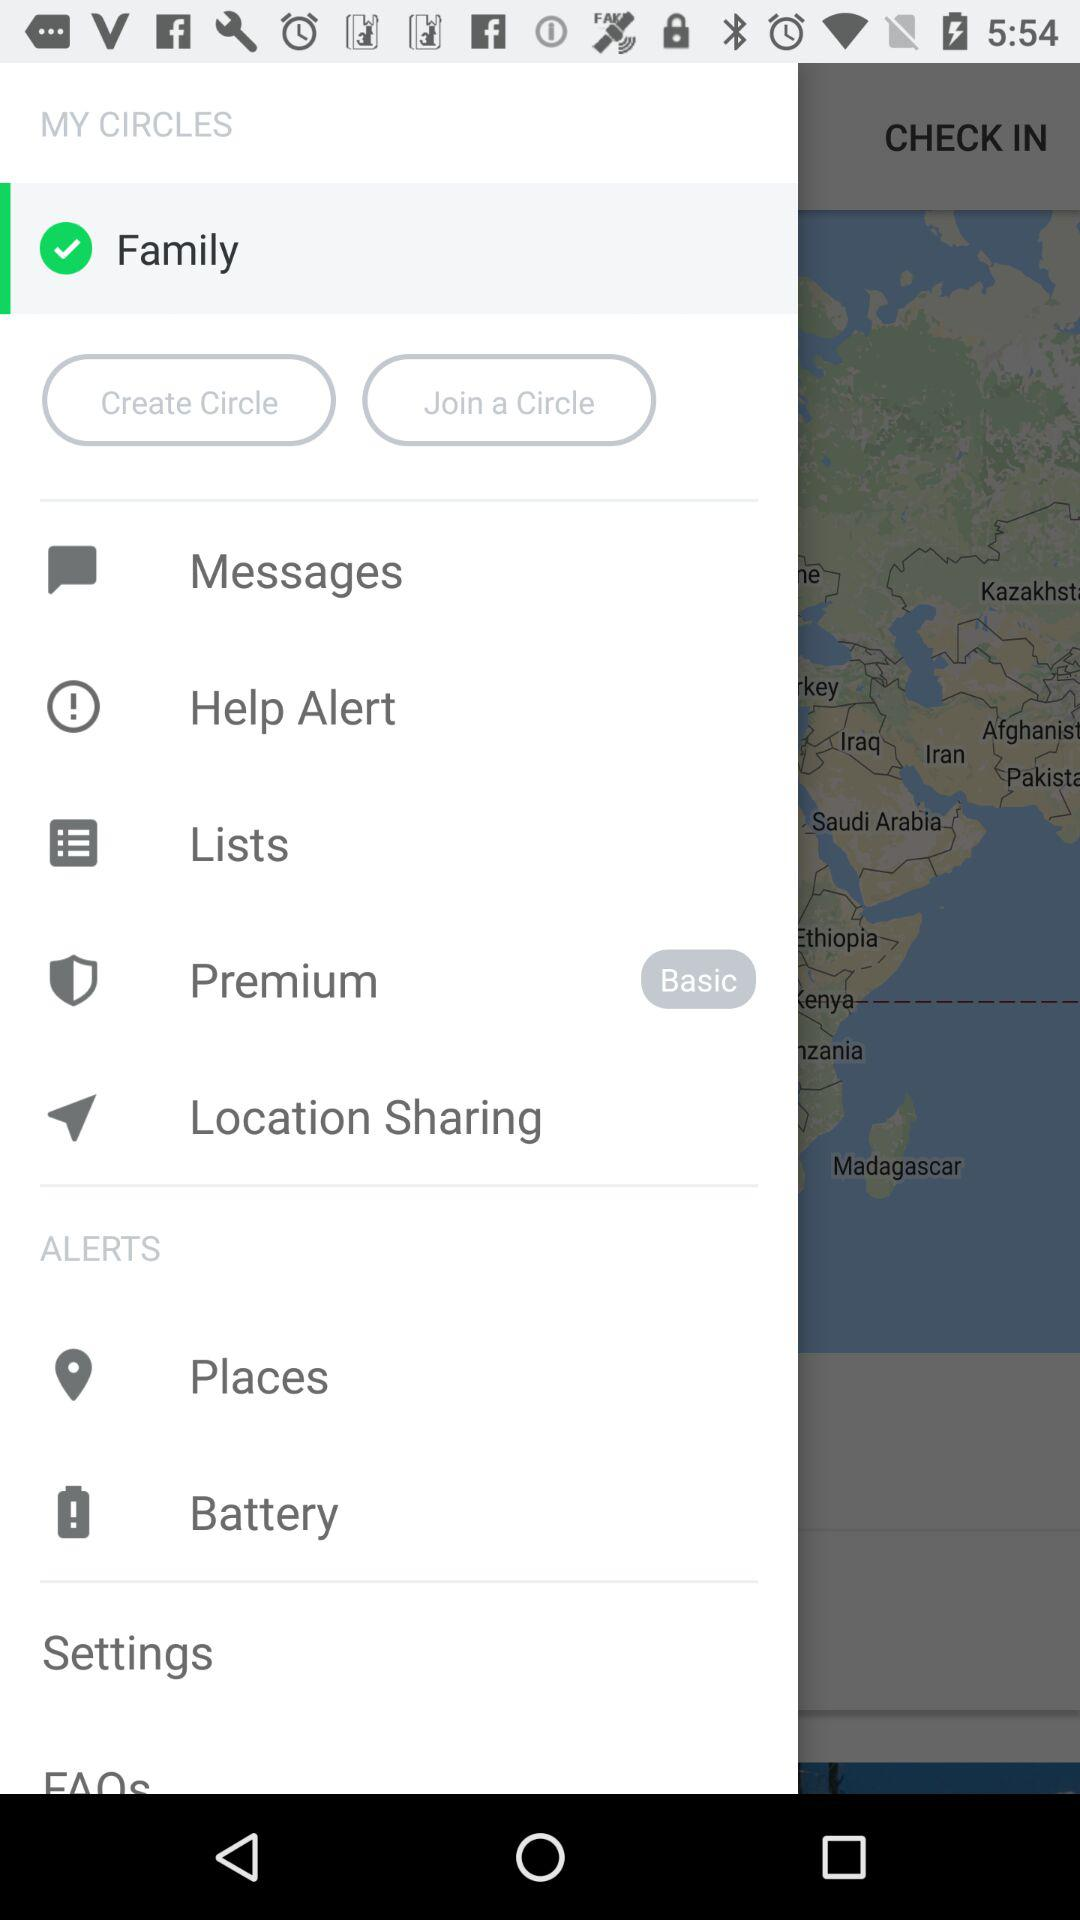What is the selected type of premium? The selected type of premium is "Basic". 